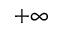Convert formula to latex. <formula><loc_0><loc_0><loc_500><loc_500>+ \infty</formula> 